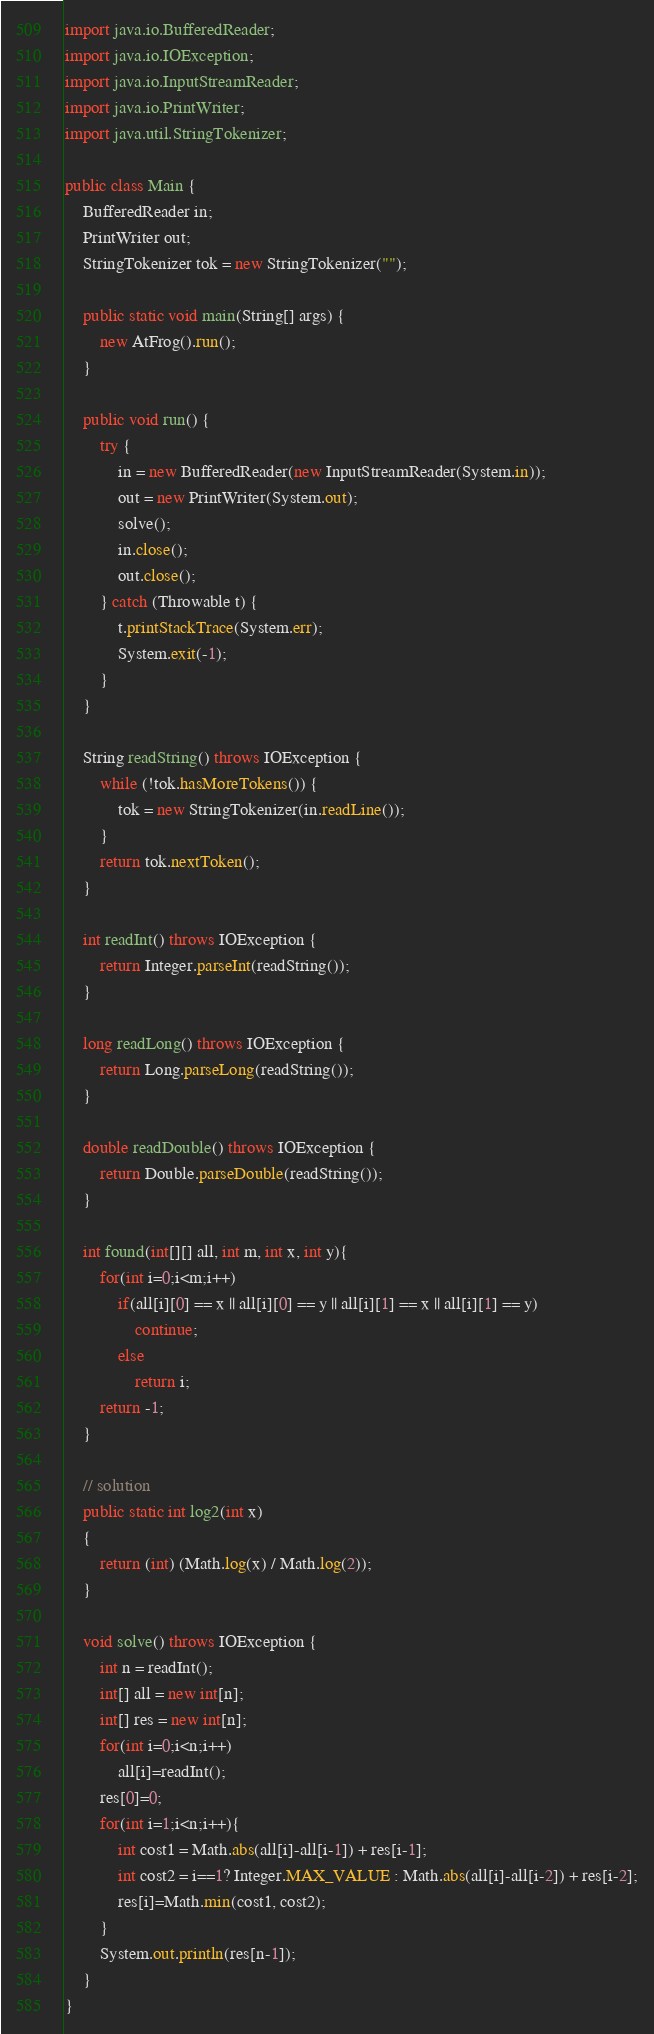Convert code to text. <code><loc_0><loc_0><loc_500><loc_500><_Java_>
import java.io.BufferedReader;
import java.io.IOException;
import java.io.InputStreamReader;
import java.io.PrintWriter;
import java.util.StringTokenizer;

public class Main {
    BufferedReader in;
    PrintWriter out;
    StringTokenizer tok = new StringTokenizer("");

    public static void main(String[] args) {
        new AtFrog().run();
    }

    public void run() {
        try {
            in = new BufferedReader(new InputStreamReader(System.in));
            out = new PrintWriter(System.out);
            solve();
            in.close();
            out.close();
        } catch (Throwable t) {
            t.printStackTrace(System.err);
            System.exit(-1);
        }
    }

    String readString() throws IOException {
        while (!tok.hasMoreTokens()) {
            tok = new StringTokenizer(in.readLine());
        }
        return tok.nextToken();
    }

    int readInt() throws IOException {
        return Integer.parseInt(readString());
    }

    long readLong() throws IOException {
        return Long.parseLong(readString());
    }

    double readDouble() throws IOException {
        return Double.parseDouble(readString());
    }

    int found(int[][] all, int m, int x, int y){
        for(int i=0;i<m;i++)
            if(all[i][0] == x || all[i][0] == y || all[i][1] == x || all[i][1] == y)
                continue;
            else
                return i;
        return -1;
    }

    // solution
    public static int log2(int x)
    {
        return (int) (Math.log(x) / Math.log(2));
    }

    void solve() throws IOException {
        int n = readInt();
        int[] all = new int[n];
        int[] res = new int[n];
        for(int i=0;i<n;i++)
            all[i]=readInt();
        res[0]=0;
        for(int i=1;i<n;i++){
            int cost1 = Math.abs(all[i]-all[i-1]) + res[i-1];
            int cost2 = i==1? Integer.MAX_VALUE : Math.abs(all[i]-all[i-2]) + res[i-2];
            res[i]=Math.min(cost1, cost2);
        }
        System.out.println(res[n-1]);
    }
}
</code> 